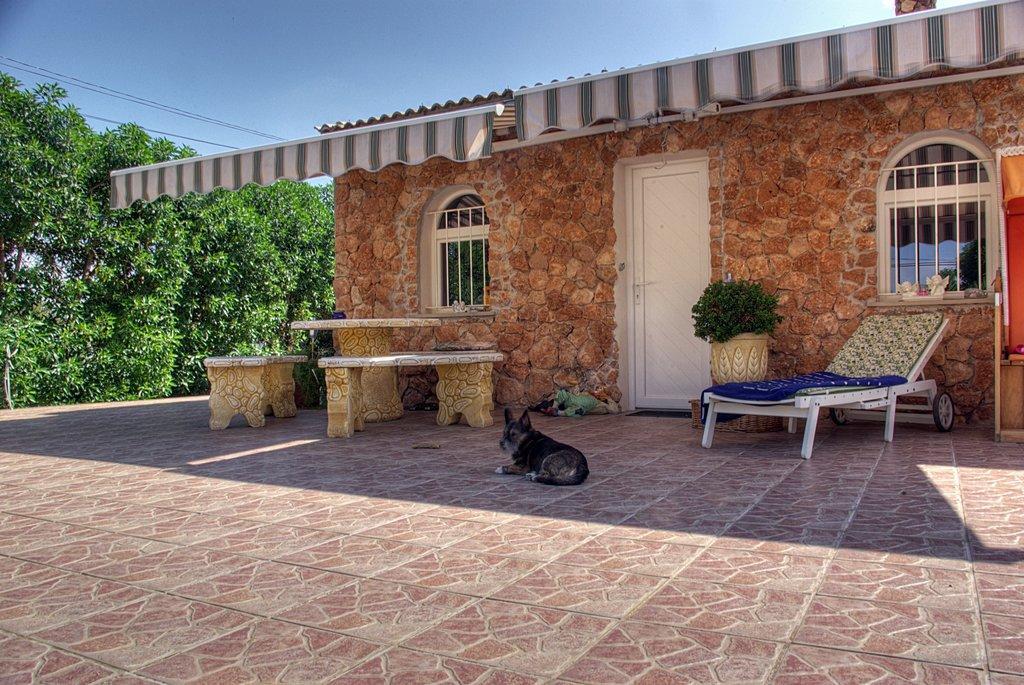Could you give a brief overview of what you see in this image? In this picture I can see a house and couple of benches and a table and I can see a chair and a plant in the pot and I can see a dog and few trees and a blue sky. 